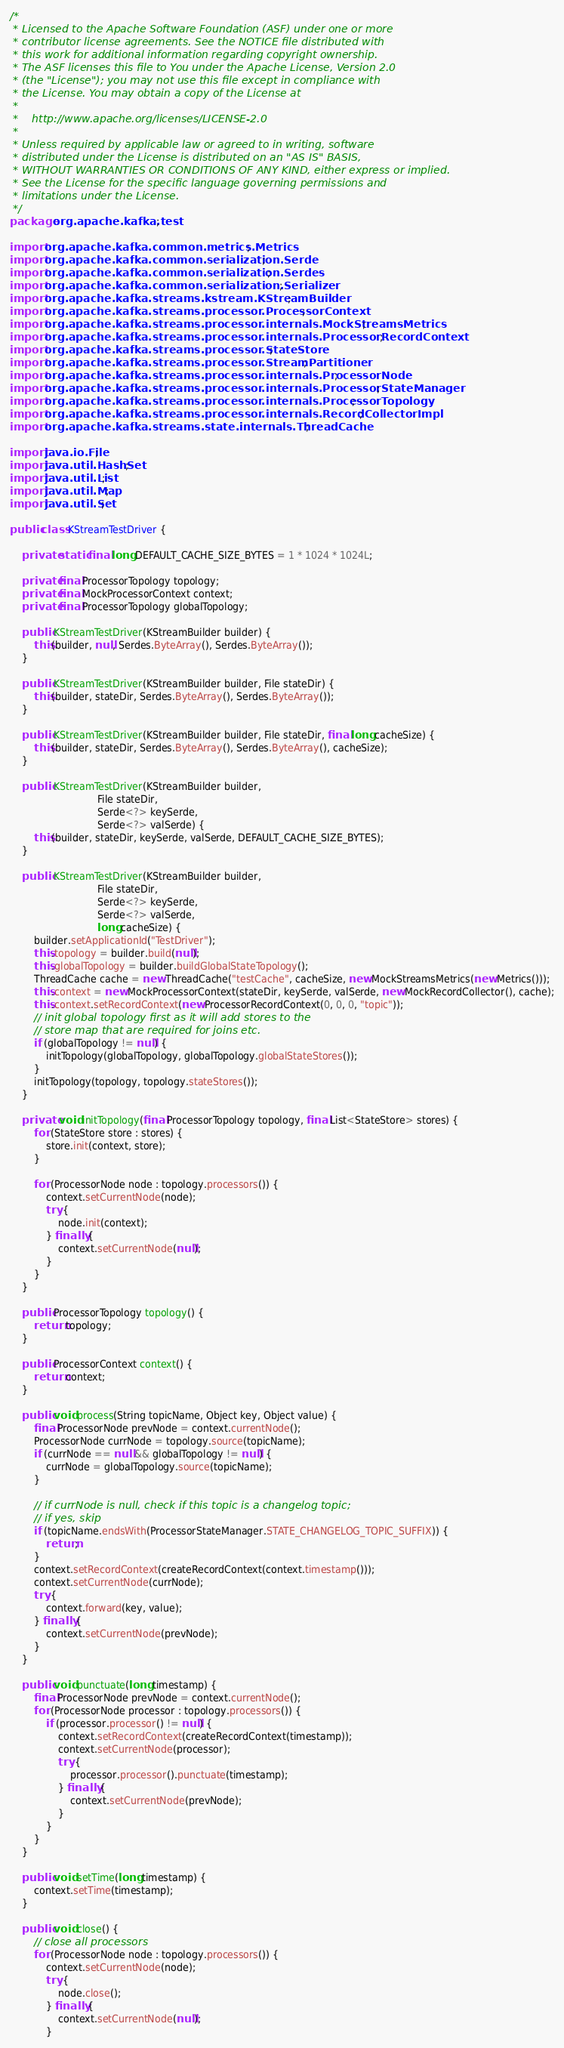<code> <loc_0><loc_0><loc_500><loc_500><_Java_>/*
 * Licensed to the Apache Software Foundation (ASF) under one or more
 * contributor license agreements. See the NOTICE file distributed with
 * this work for additional information regarding copyright ownership.
 * The ASF licenses this file to You under the Apache License, Version 2.0
 * (the "License"); you may not use this file except in compliance with
 * the License. You may obtain a copy of the License at
 *
 *    http://www.apache.org/licenses/LICENSE-2.0
 *
 * Unless required by applicable law or agreed to in writing, software
 * distributed under the License is distributed on an "AS IS" BASIS,
 * WITHOUT WARRANTIES OR CONDITIONS OF ANY KIND, either express or implied.
 * See the License for the specific language governing permissions and
 * limitations under the License.
 */
package org.apache.kafka.test;

import org.apache.kafka.common.metrics.Metrics;
import org.apache.kafka.common.serialization.Serde;
import org.apache.kafka.common.serialization.Serdes;
import org.apache.kafka.common.serialization.Serializer;
import org.apache.kafka.streams.kstream.KStreamBuilder;
import org.apache.kafka.streams.processor.ProcessorContext;
import org.apache.kafka.streams.processor.internals.MockStreamsMetrics;
import org.apache.kafka.streams.processor.internals.ProcessorRecordContext;
import org.apache.kafka.streams.processor.StateStore;
import org.apache.kafka.streams.processor.StreamPartitioner;
import org.apache.kafka.streams.processor.internals.ProcessorNode;
import org.apache.kafka.streams.processor.internals.ProcessorStateManager;
import org.apache.kafka.streams.processor.internals.ProcessorTopology;
import org.apache.kafka.streams.processor.internals.RecordCollectorImpl;
import org.apache.kafka.streams.state.internals.ThreadCache;

import java.io.File;
import java.util.HashSet;
import java.util.List;
import java.util.Map;
import java.util.Set;

public class KStreamTestDriver {

    private static final long DEFAULT_CACHE_SIZE_BYTES = 1 * 1024 * 1024L;

    private final ProcessorTopology topology;
    private final MockProcessorContext context;
    private final ProcessorTopology globalTopology;

    public KStreamTestDriver(KStreamBuilder builder) {
        this(builder, null, Serdes.ByteArray(), Serdes.ByteArray());
    }

    public KStreamTestDriver(KStreamBuilder builder, File stateDir) {
        this(builder, stateDir, Serdes.ByteArray(), Serdes.ByteArray());
    }

    public KStreamTestDriver(KStreamBuilder builder, File stateDir, final long cacheSize) {
        this(builder, stateDir, Serdes.ByteArray(), Serdes.ByteArray(), cacheSize);
    }

    public KStreamTestDriver(KStreamBuilder builder,
                             File stateDir,
                             Serde<?> keySerde,
                             Serde<?> valSerde) {
        this(builder, stateDir, keySerde, valSerde, DEFAULT_CACHE_SIZE_BYTES);
    }

    public KStreamTestDriver(KStreamBuilder builder,
                             File stateDir,
                             Serde<?> keySerde,
                             Serde<?> valSerde,
                             long cacheSize) {
        builder.setApplicationId("TestDriver");
        this.topology = builder.build(null);
        this.globalTopology = builder.buildGlobalStateTopology();
        ThreadCache cache = new ThreadCache("testCache", cacheSize, new MockStreamsMetrics(new Metrics()));
        this.context = new MockProcessorContext(stateDir, keySerde, valSerde, new MockRecordCollector(), cache);
        this.context.setRecordContext(new ProcessorRecordContext(0, 0, 0, "topic"));
        // init global topology first as it will add stores to the
        // store map that are required for joins etc.
        if (globalTopology != null) {
            initTopology(globalTopology, globalTopology.globalStateStores());
        }
        initTopology(topology, topology.stateStores());
    }

    private void initTopology(final ProcessorTopology topology, final List<StateStore> stores) {
        for (StateStore store : stores) {
            store.init(context, store);
        }

        for (ProcessorNode node : topology.processors()) {
            context.setCurrentNode(node);
            try {
                node.init(context);
            } finally {
                context.setCurrentNode(null);
            }
        }
    }

    public ProcessorTopology topology() {
        return topology;
    }

    public ProcessorContext context() {
        return context;
    }

    public void process(String topicName, Object key, Object value) {
        final ProcessorNode prevNode = context.currentNode();
        ProcessorNode currNode = topology.source(topicName);
        if (currNode == null && globalTopology != null) {
            currNode = globalTopology.source(topicName);
        }

        // if currNode is null, check if this topic is a changelog topic;
        // if yes, skip
        if (topicName.endsWith(ProcessorStateManager.STATE_CHANGELOG_TOPIC_SUFFIX)) {
            return;
        }
        context.setRecordContext(createRecordContext(context.timestamp()));
        context.setCurrentNode(currNode);
        try {
            context.forward(key, value);
        } finally {
            context.setCurrentNode(prevNode);
        }
    }

    public void punctuate(long timestamp) {
        final ProcessorNode prevNode = context.currentNode();
        for (ProcessorNode processor : topology.processors()) {
            if (processor.processor() != null) {
                context.setRecordContext(createRecordContext(timestamp));
                context.setCurrentNode(processor);
                try {
                    processor.processor().punctuate(timestamp);
                } finally {
                    context.setCurrentNode(prevNode);
                }
            }
        }
    }

    public void setTime(long timestamp) {
        context.setTime(timestamp);
    }

    public void close() {
        // close all processors
        for (ProcessorNode node : topology.processors()) {
            context.setCurrentNode(node);
            try {
                node.close();
            } finally {
                context.setCurrentNode(null);
            }</code> 